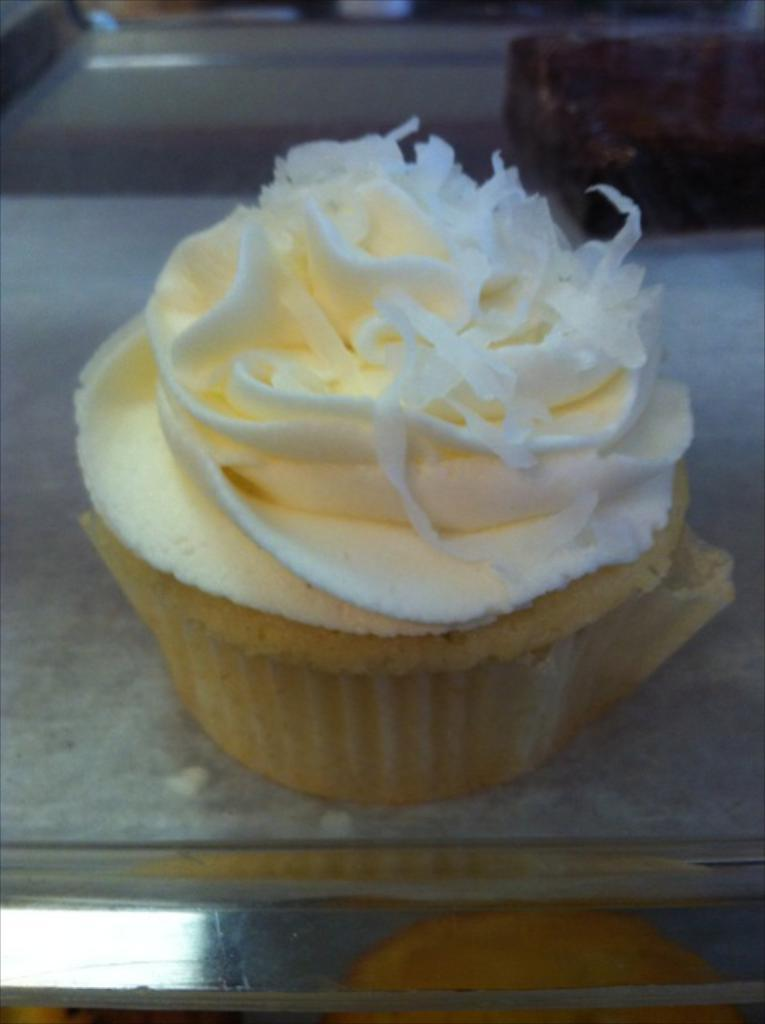What type of dessert is in the image? There is an ice cream in a cup in the image. Where is the ice cream cup located? The ice cream cup is placed on a table. Can you describe the background of the image? The background of the image is blurred. What type of songs can be heard coming from the geese in the image? There are no geese present in the image, so it's not possible to determine what, if any, songs might be heard. 